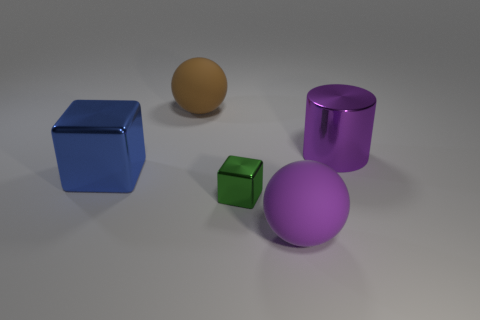How many large spheres are the same color as the big cylinder?
Give a very brief answer. 1. There is a rubber object that is the same color as the big shiny cylinder; what is its size?
Give a very brief answer. Large. Does the big metallic cylinder have the same color as the small cube?
Your answer should be very brief. No. Is the material of the large purple object that is on the left side of the big purple shiny cylinder the same as the object that is on the left side of the big brown object?
Provide a succinct answer. No. How many things are either big purple matte things or large cylinders behind the small shiny cube?
Your response must be concise. 2. Are there any other things that have the same material as the large purple sphere?
Offer a terse response. Yes. What material is the green cube?
Offer a very short reply. Metal. Does the brown object have the same material as the big cylinder?
Give a very brief answer. No. What number of shiny things are tiny blue blocks or big cylinders?
Provide a succinct answer. 1. The big metallic thing to the right of the blue cube has what shape?
Give a very brief answer. Cylinder. 